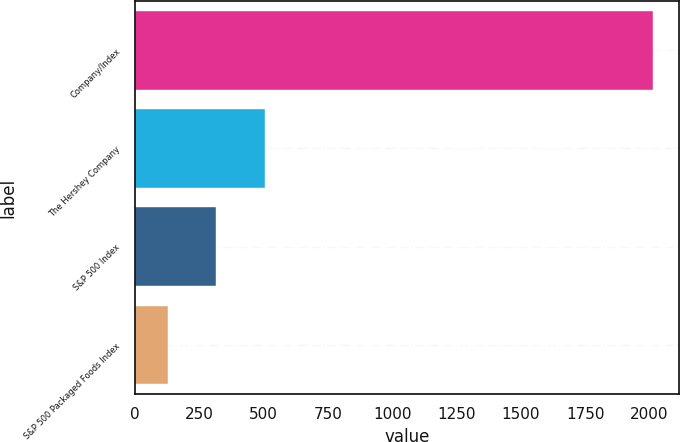Convert chart to OTSL. <chart><loc_0><loc_0><loc_500><loc_500><bar_chart><fcel>Company/Index<fcel>The Hershey Company<fcel>S&P 500 Index<fcel>S&P 500 Packaged Foods Index<nl><fcel>2013<fcel>503.4<fcel>314.7<fcel>126<nl></chart> 